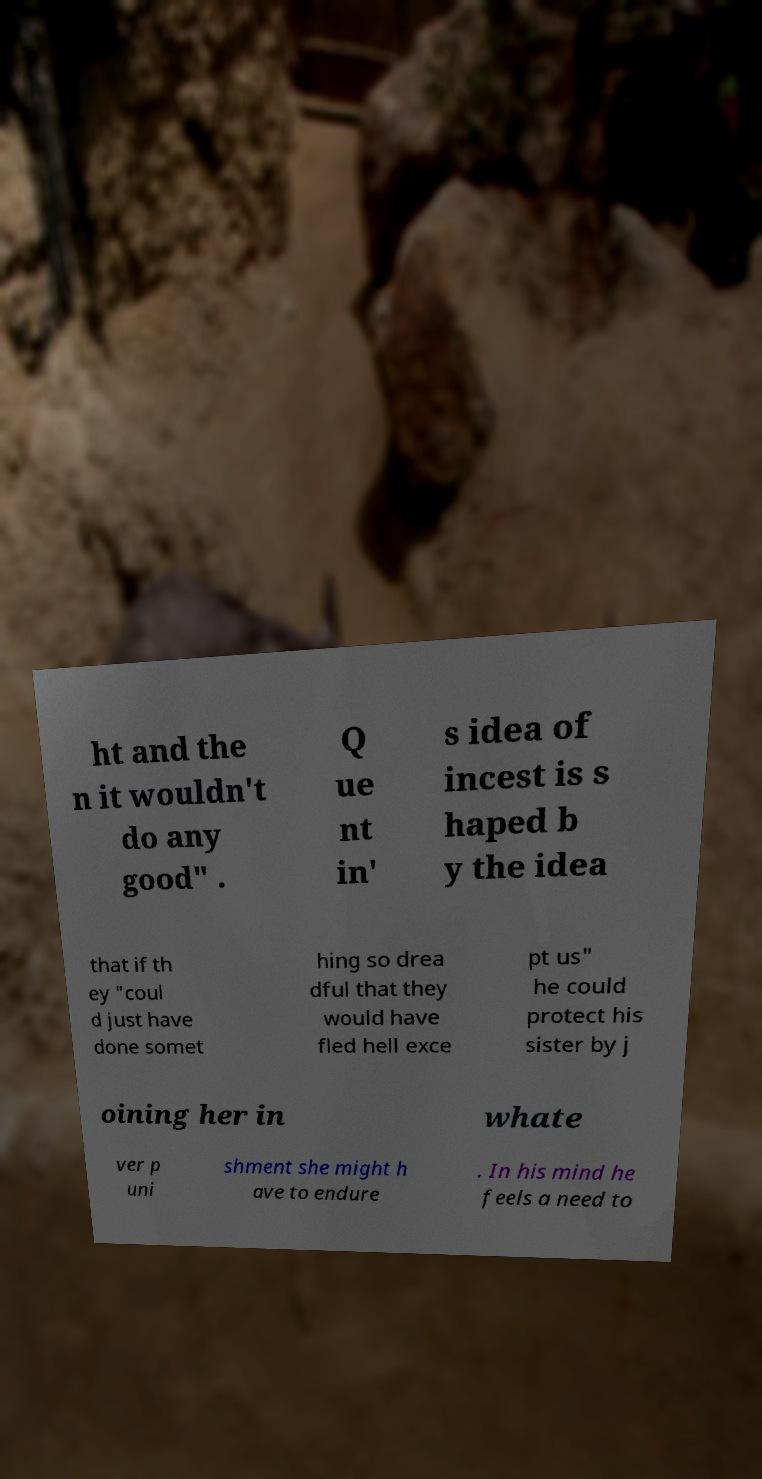Could you extract and type out the text from this image? ht and the n it wouldn't do any good" . Q ue nt in' s idea of incest is s haped b y the idea that if th ey "coul d just have done somet hing so drea dful that they would have fled hell exce pt us" he could protect his sister by j oining her in whate ver p uni shment she might h ave to endure . In his mind he feels a need to 